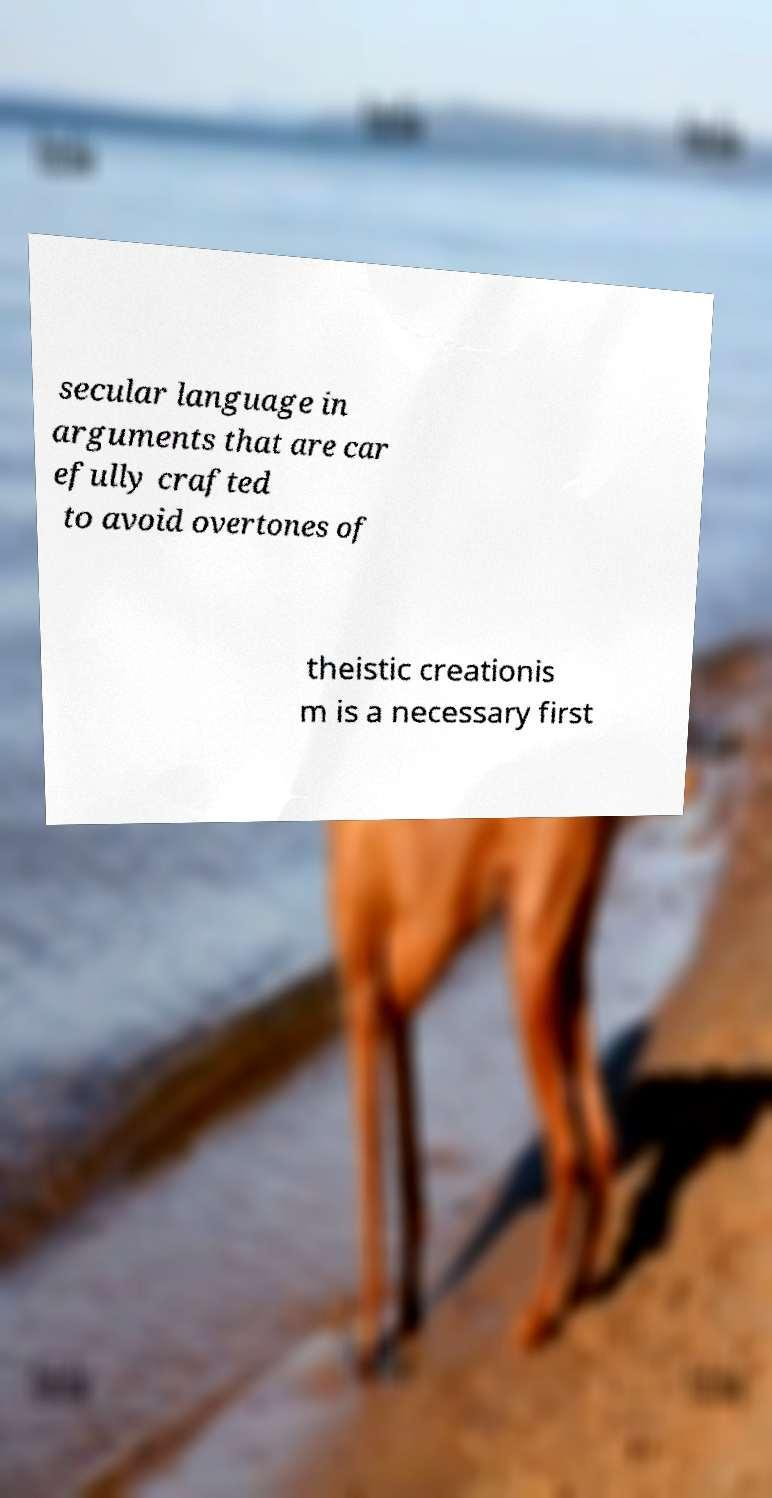Can you read and provide the text displayed in the image?This photo seems to have some interesting text. Can you extract and type it out for me? secular language in arguments that are car efully crafted to avoid overtones of theistic creationis m is a necessary first 